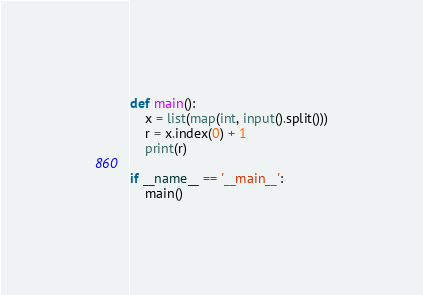<code> <loc_0><loc_0><loc_500><loc_500><_Python_>def main():
    x = list(map(int, input().split()))
    r = x.index(0) + 1
    print(r)

if __name__ == '__main__':
    main()
</code> 